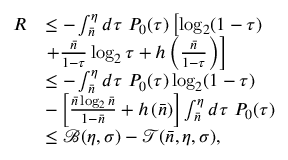<formula> <loc_0><loc_0><loc_500><loc_500>\begin{array} { r l } { R } & { \leq - \int _ { \bar { n } } ^ { \eta } d \tau P _ { 0 } ( \tau ) \left [ \log _ { 2 } ( 1 - \tau ) } \\ & { + \frac { \bar { n } } { 1 - \tau } \log _ { 2 } \tau + h \left ( \frac { \bar { n } } { 1 - \tau } \right ) \right ] } \\ & { \leq - \int _ { \bar { n } } ^ { \eta } d \tau P _ { 0 } ( \tau ) \log _ { 2 } ( 1 - \tau ) } \\ & { - \left [ \frac { \bar { n } \log _ { 2 } \bar { n } } { 1 - \bar { n } } + h \left ( \bar { n } \right ) \right ] \int _ { \bar { n } } ^ { \eta } d \tau P _ { 0 } ( \tau ) } \\ & { \leq \mathcal { B } ( \eta , \sigma ) - \mathcal { T } ( \bar { n } , \eta , \sigma ) , } \end{array}</formula> 